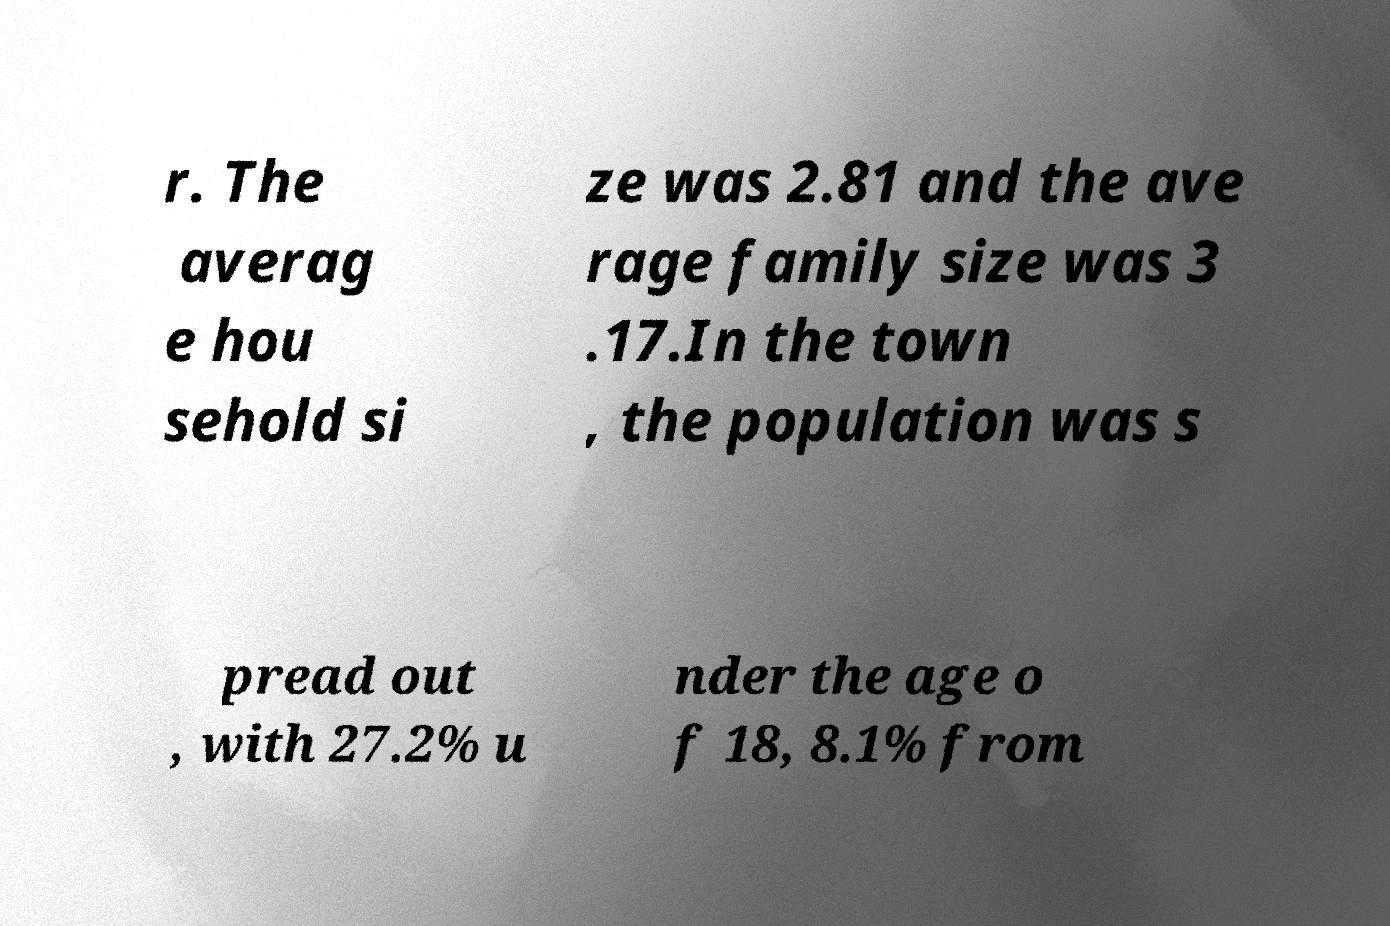Could you assist in decoding the text presented in this image and type it out clearly? r. The averag e hou sehold si ze was 2.81 and the ave rage family size was 3 .17.In the town , the population was s pread out , with 27.2% u nder the age o f 18, 8.1% from 